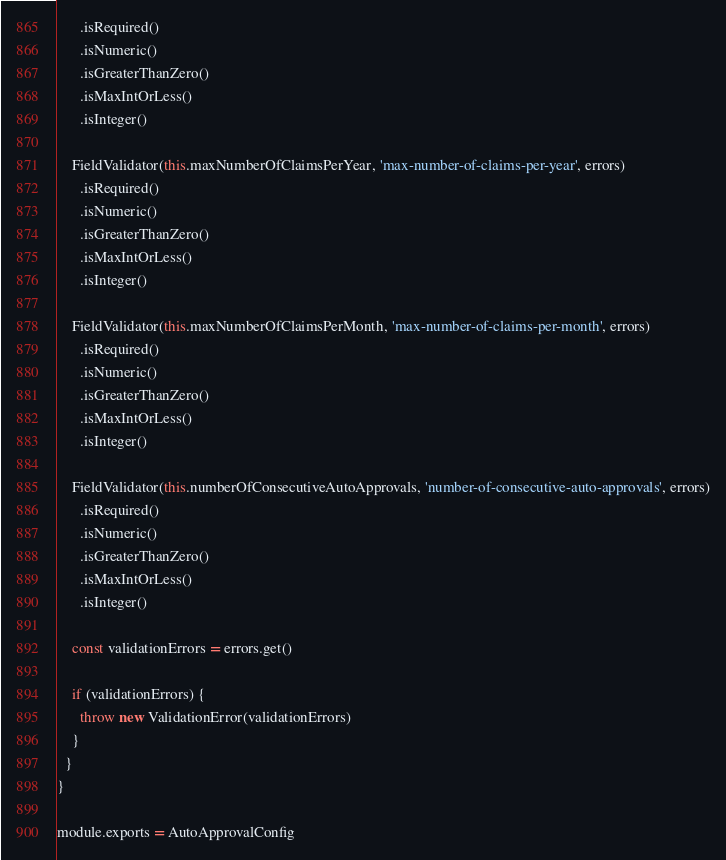<code> <loc_0><loc_0><loc_500><loc_500><_JavaScript_>      .isRequired()
      .isNumeric()
      .isGreaterThanZero()
      .isMaxIntOrLess()
      .isInteger()

    FieldValidator(this.maxNumberOfClaimsPerYear, 'max-number-of-claims-per-year', errors)
      .isRequired()
      .isNumeric()
      .isGreaterThanZero()
      .isMaxIntOrLess()
      .isInteger()

    FieldValidator(this.maxNumberOfClaimsPerMonth, 'max-number-of-claims-per-month', errors)
      .isRequired()
      .isNumeric()
      .isGreaterThanZero()
      .isMaxIntOrLess()
      .isInteger()

    FieldValidator(this.numberOfConsecutiveAutoApprovals, 'number-of-consecutive-auto-approvals', errors)
      .isRequired()
      .isNumeric()
      .isGreaterThanZero()
      .isMaxIntOrLess()
      .isInteger()

    const validationErrors = errors.get()

    if (validationErrors) {
      throw new ValidationError(validationErrors)
    }
  }
}

module.exports = AutoApprovalConfig
</code> 